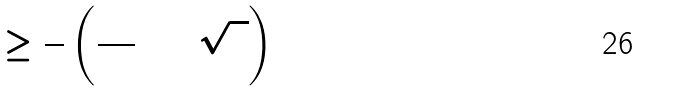<formula> <loc_0><loc_0><loc_500><loc_500>\Theta _ { 0 } \geq \frac { 2 } { 9 } \left ( \frac { 2 5 } { 3 } + 5 \sqrt { 3 } \right )</formula> 